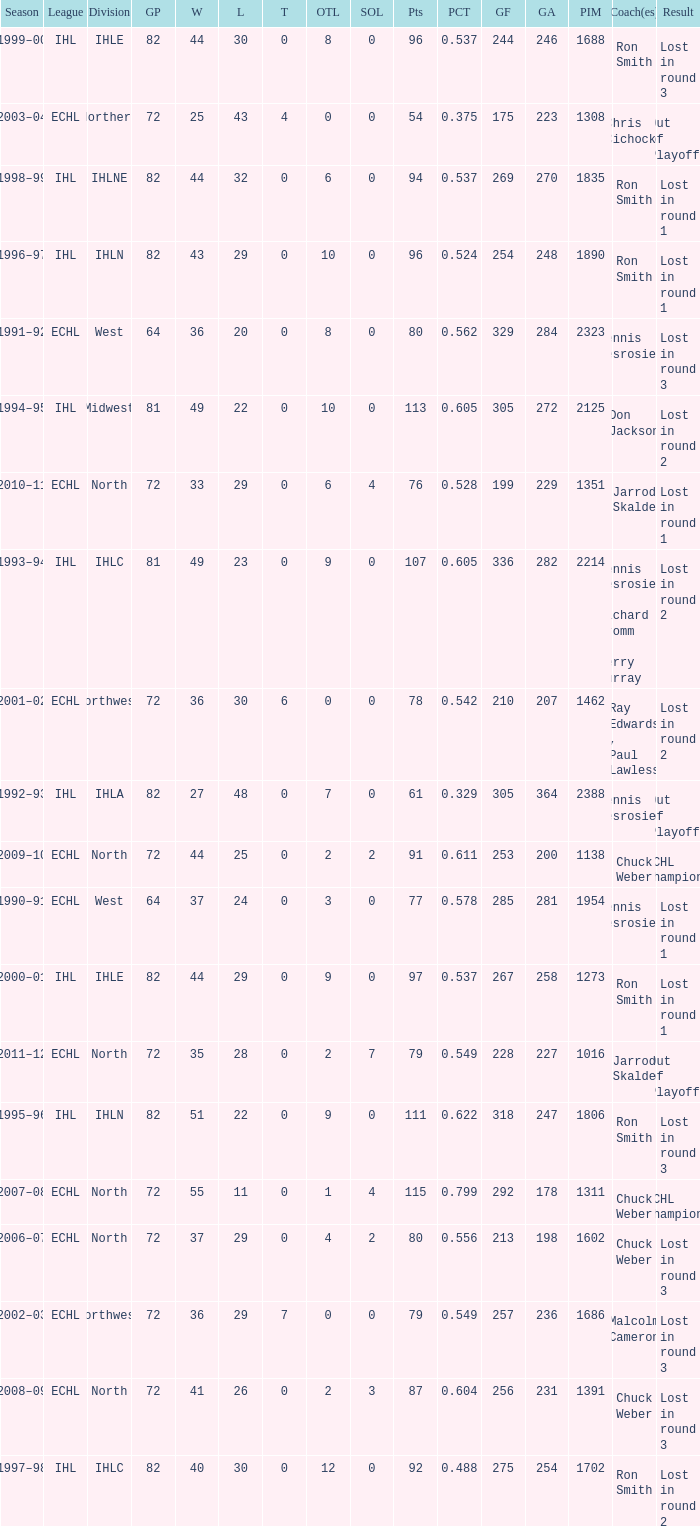How many season did the team lost in round 1 with a GP of 64? 1.0. 